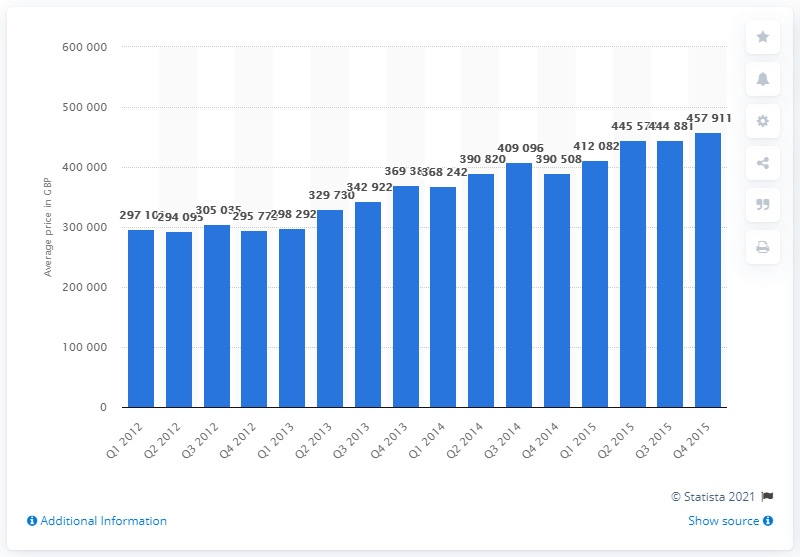Highlight a few significant elements in this photo. The average price of a residential property in Greater London at the end of the fourth quarter of 2015 was 457,911. In the fourth quarter of 2014, the average price of a residential property in Greater London was approximately 390,508. 